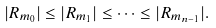Convert formula to latex. <formula><loc_0><loc_0><loc_500><loc_500>| R _ { m _ { 0 } } | \leq | R _ { m _ { 1 } } | \leq \dots \leq | R _ { m _ { n - 1 } } | .</formula> 